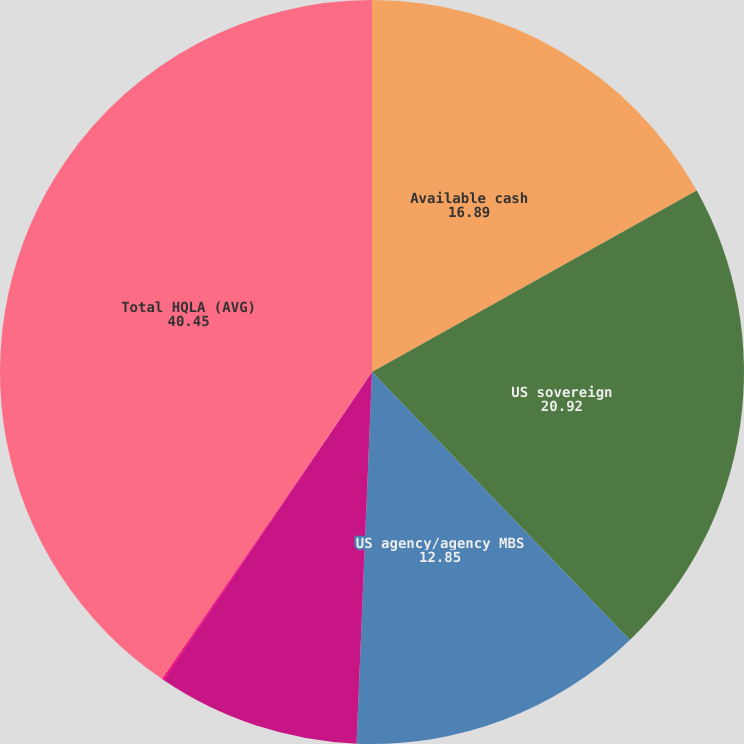Convert chart to OTSL. <chart><loc_0><loc_0><loc_500><loc_500><pie_chart><fcel>Available cash<fcel>US sovereign<fcel>US agency/agency MBS<fcel>Foreign government debt (1)<fcel>Other investment grade<fcel>Total HQLA (AVG)<nl><fcel>16.89%<fcel>20.92%<fcel>12.85%<fcel>8.81%<fcel>0.08%<fcel>40.45%<nl></chart> 